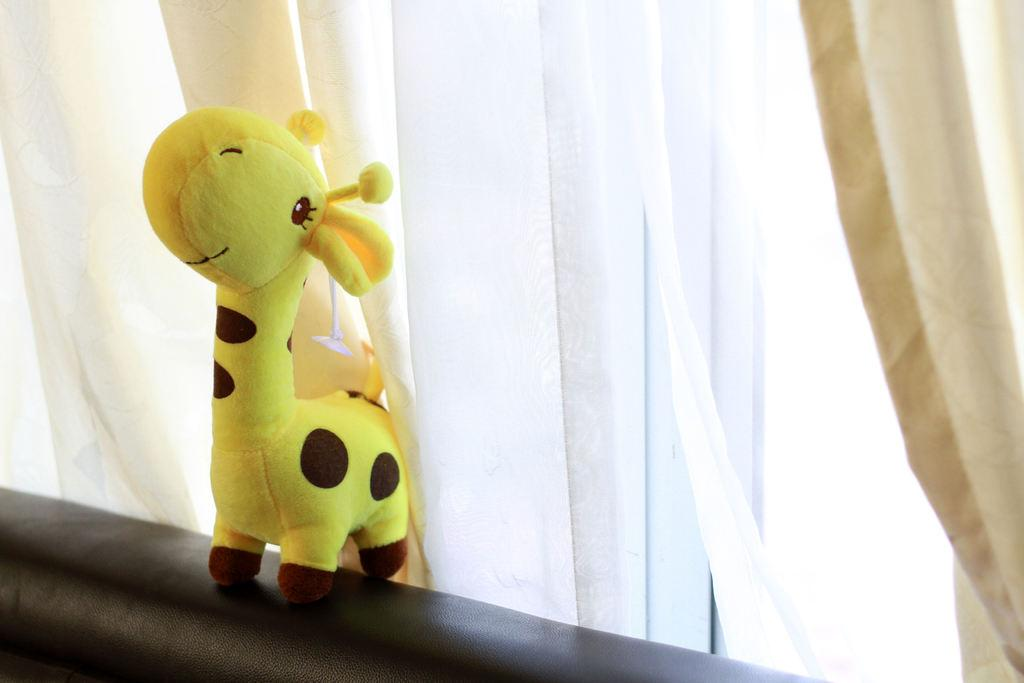What object can be seen on the left side of the image? There is a toy on the left side of the image. What colors are present on the toy? The toy is yellow and black in color. What can be seen in the background of the image? There are white color curtains in the background of the image. Can you see a monkey swinging from a branch in the image? No, there is no monkey or branch present in the image. 